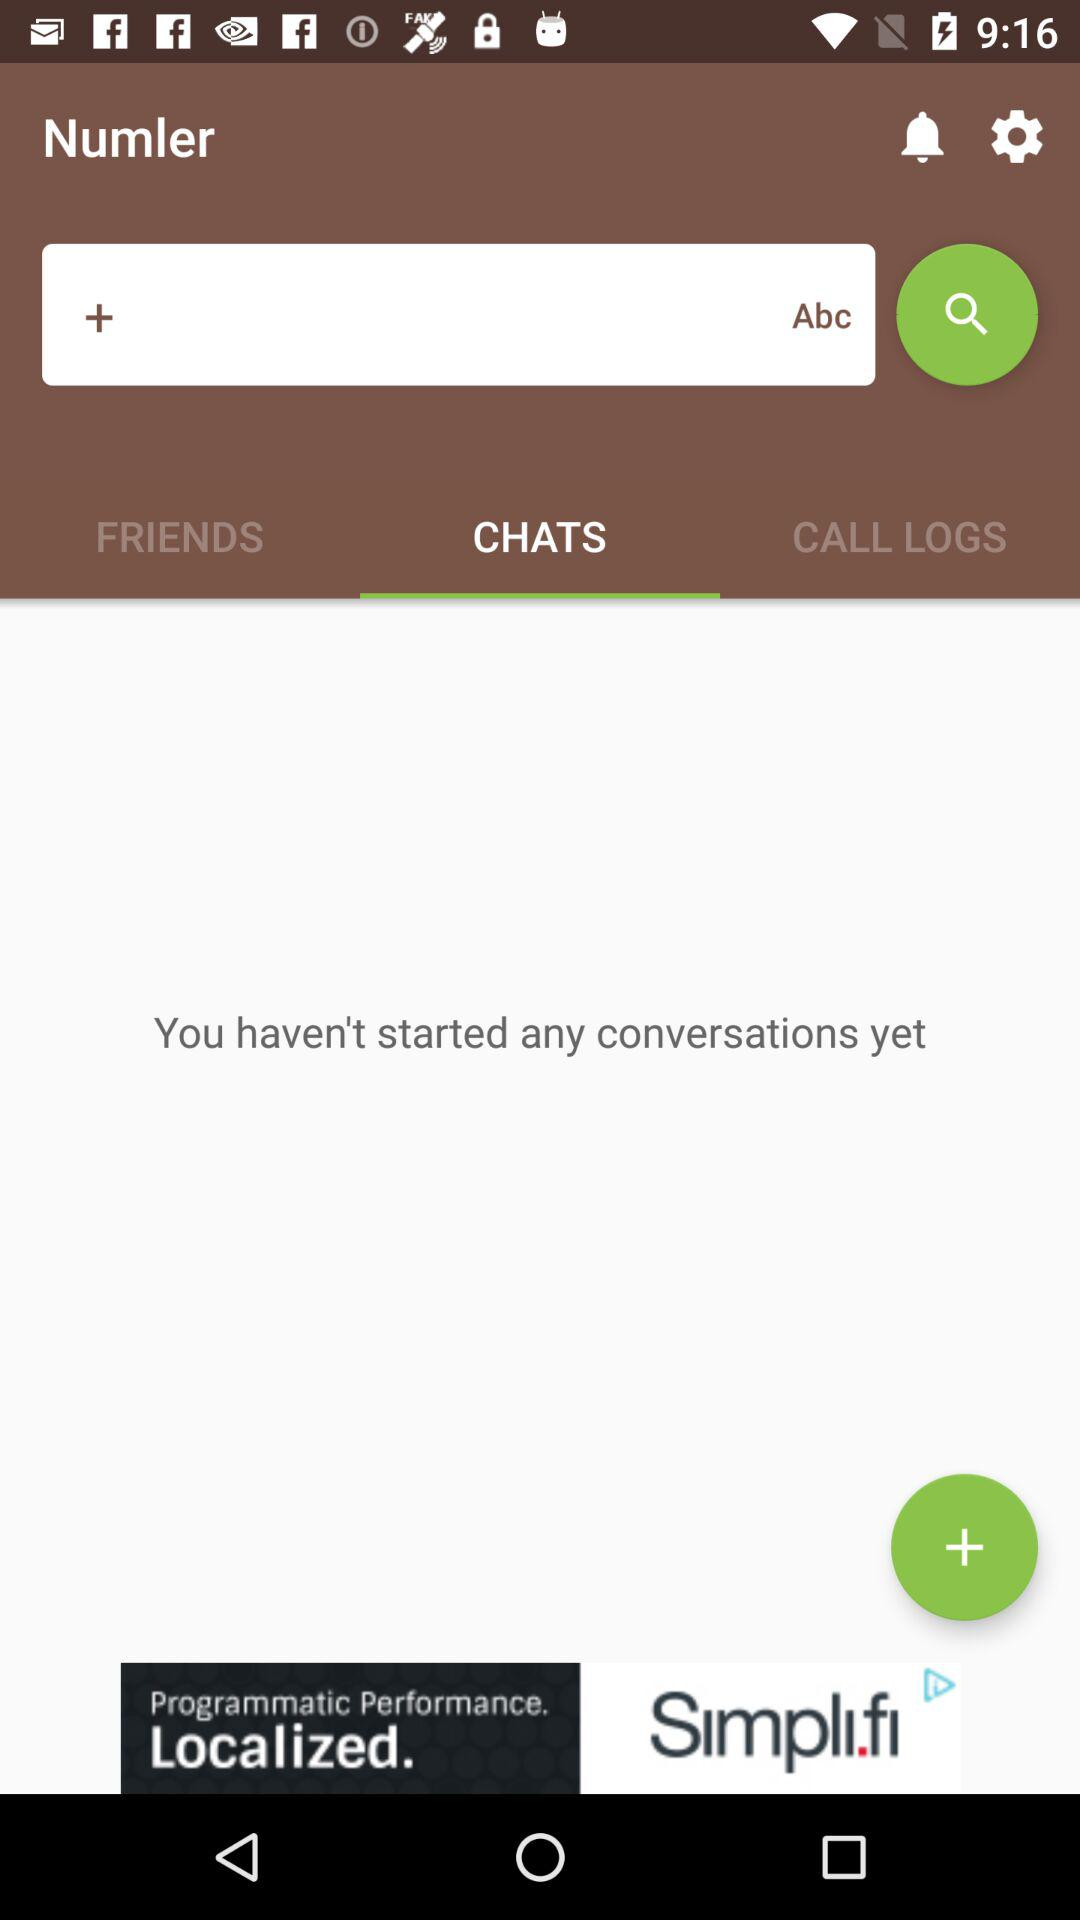What is the application name? The application name is "Numler". 